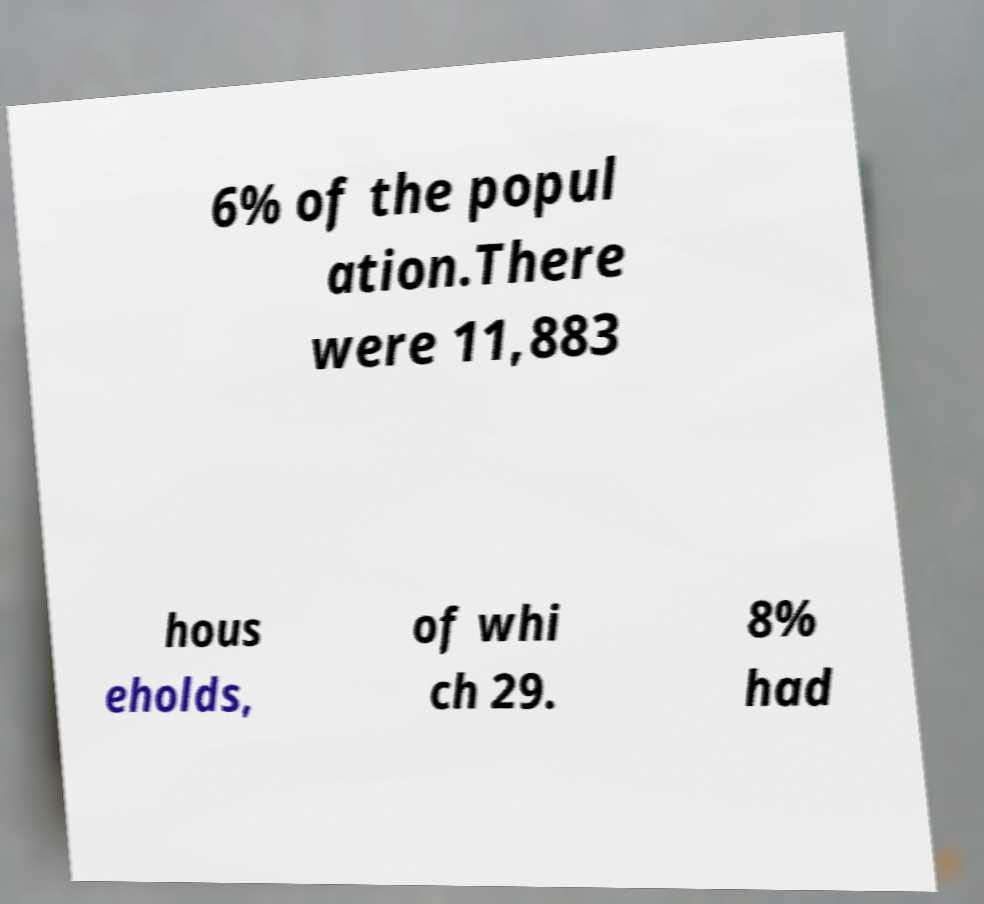Can you read and provide the text displayed in the image?This photo seems to have some interesting text. Can you extract and type it out for me? 6% of the popul ation.There were 11,883 hous eholds, of whi ch 29. 8% had 